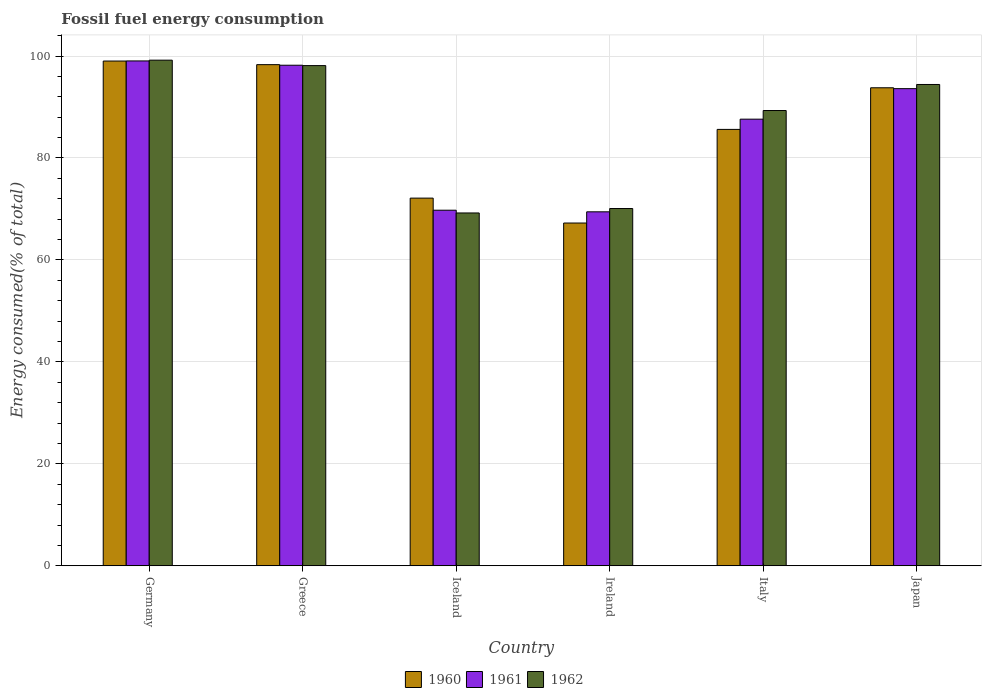How many different coloured bars are there?
Provide a succinct answer. 3. How many bars are there on the 1st tick from the left?
Your answer should be compact. 3. What is the percentage of energy consumed in 1960 in Ireland?
Offer a very short reply. 67.24. Across all countries, what is the maximum percentage of energy consumed in 1960?
Keep it short and to the point. 99.02. Across all countries, what is the minimum percentage of energy consumed in 1961?
Offer a very short reply. 69.44. In which country was the percentage of energy consumed in 1960 maximum?
Your answer should be very brief. Germany. In which country was the percentage of energy consumed in 1961 minimum?
Your response must be concise. Ireland. What is the total percentage of energy consumed in 1960 in the graph?
Give a very brief answer. 516.09. What is the difference between the percentage of energy consumed in 1960 in Iceland and that in Ireland?
Offer a terse response. 4.89. What is the difference between the percentage of energy consumed in 1961 in Greece and the percentage of energy consumed in 1960 in Italy?
Your answer should be compact. 12.59. What is the average percentage of energy consumed in 1961 per country?
Provide a short and direct response. 86.28. What is the difference between the percentage of energy consumed of/in 1961 and percentage of energy consumed of/in 1962 in Iceland?
Provide a short and direct response. 0.54. In how many countries, is the percentage of energy consumed in 1960 greater than 72 %?
Your answer should be very brief. 5. What is the ratio of the percentage of energy consumed in 1961 in Germany to that in Iceland?
Provide a short and direct response. 1.42. What is the difference between the highest and the second highest percentage of energy consumed in 1962?
Ensure brevity in your answer.  -1.07. What is the difference between the highest and the lowest percentage of energy consumed in 1961?
Your answer should be compact. 29.6. In how many countries, is the percentage of energy consumed in 1962 greater than the average percentage of energy consumed in 1962 taken over all countries?
Keep it short and to the point. 4. How many bars are there?
Offer a very short reply. 18. How many countries are there in the graph?
Give a very brief answer. 6. Does the graph contain any zero values?
Your answer should be compact. No. Does the graph contain grids?
Provide a succinct answer. Yes. Where does the legend appear in the graph?
Your response must be concise. Bottom center. What is the title of the graph?
Your answer should be compact. Fossil fuel energy consumption. What is the label or title of the Y-axis?
Make the answer very short. Energy consumed(% of total). What is the Energy consumed(% of total) of 1960 in Germany?
Give a very brief answer. 99.02. What is the Energy consumed(% of total) of 1961 in Germany?
Offer a terse response. 99.04. What is the Energy consumed(% of total) in 1962 in Germany?
Keep it short and to the point. 99.19. What is the Energy consumed(% of total) of 1960 in Greece?
Make the answer very short. 98.31. What is the Energy consumed(% of total) in 1961 in Greece?
Your answer should be very brief. 98.2. What is the Energy consumed(% of total) in 1962 in Greece?
Make the answer very short. 98.12. What is the Energy consumed(% of total) in 1960 in Iceland?
Offer a terse response. 72.13. What is the Energy consumed(% of total) of 1961 in Iceland?
Provide a succinct answer. 69.76. What is the Energy consumed(% of total) of 1962 in Iceland?
Provide a succinct answer. 69.22. What is the Energy consumed(% of total) in 1960 in Ireland?
Your answer should be compact. 67.24. What is the Energy consumed(% of total) in 1961 in Ireland?
Offer a terse response. 69.44. What is the Energy consumed(% of total) in 1962 in Ireland?
Ensure brevity in your answer.  70.09. What is the Energy consumed(% of total) of 1960 in Italy?
Give a very brief answer. 85.61. What is the Energy consumed(% of total) in 1961 in Italy?
Your answer should be compact. 87.62. What is the Energy consumed(% of total) in 1962 in Italy?
Your answer should be compact. 89.31. What is the Energy consumed(% of total) of 1960 in Japan?
Make the answer very short. 93.78. What is the Energy consumed(% of total) of 1961 in Japan?
Your answer should be compact. 93.6. What is the Energy consumed(% of total) of 1962 in Japan?
Your answer should be very brief. 94.42. Across all countries, what is the maximum Energy consumed(% of total) of 1960?
Give a very brief answer. 99.02. Across all countries, what is the maximum Energy consumed(% of total) in 1961?
Your answer should be very brief. 99.04. Across all countries, what is the maximum Energy consumed(% of total) in 1962?
Keep it short and to the point. 99.19. Across all countries, what is the minimum Energy consumed(% of total) of 1960?
Provide a short and direct response. 67.24. Across all countries, what is the minimum Energy consumed(% of total) of 1961?
Your answer should be compact. 69.44. Across all countries, what is the minimum Energy consumed(% of total) of 1962?
Your answer should be very brief. 69.22. What is the total Energy consumed(% of total) in 1960 in the graph?
Provide a short and direct response. 516.09. What is the total Energy consumed(% of total) in 1961 in the graph?
Provide a succinct answer. 517.66. What is the total Energy consumed(% of total) of 1962 in the graph?
Your answer should be very brief. 520.35. What is the difference between the Energy consumed(% of total) of 1960 in Germany and that in Greece?
Keep it short and to the point. 0.71. What is the difference between the Energy consumed(% of total) of 1961 in Germany and that in Greece?
Your response must be concise. 0.84. What is the difference between the Energy consumed(% of total) in 1962 in Germany and that in Greece?
Provide a succinct answer. 1.07. What is the difference between the Energy consumed(% of total) in 1960 in Germany and that in Iceland?
Ensure brevity in your answer.  26.89. What is the difference between the Energy consumed(% of total) of 1961 in Germany and that in Iceland?
Keep it short and to the point. 29.28. What is the difference between the Energy consumed(% of total) of 1962 in Germany and that in Iceland?
Your response must be concise. 29.98. What is the difference between the Energy consumed(% of total) in 1960 in Germany and that in Ireland?
Keep it short and to the point. 31.78. What is the difference between the Energy consumed(% of total) of 1961 in Germany and that in Ireland?
Give a very brief answer. 29.6. What is the difference between the Energy consumed(% of total) of 1962 in Germany and that in Ireland?
Provide a short and direct response. 29.11. What is the difference between the Energy consumed(% of total) in 1960 in Germany and that in Italy?
Offer a terse response. 13.41. What is the difference between the Energy consumed(% of total) in 1961 in Germany and that in Italy?
Provide a succinct answer. 11.42. What is the difference between the Energy consumed(% of total) in 1962 in Germany and that in Italy?
Keep it short and to the point. 9.88. What is the difference between the Energy consumed(% of total) in 1960 in Germany and that in Japan?
Your answer should be compact. 5.24. What is the difference between the Energy consumed(% of total) in 1961 in Germany and that in Japan?
Keep it short and to the point. 5.44. What is the difference between the Energy consumed(% of total) in 1962 in Germany and that in Japan?
Keep it short and to the point. 4.77. What is the difference between the Energy consumed(% of total) of 1960 in Greece and that in Iceland?
Offer a very short reply. 26.18. What is the difference between the Energy consumed(% of total) of 1961 in Greece and that in Iceland?
Your answer should be compact. 28.44. What is the difference between the Energy consumed(% of total) in 1962 in Greece and that in Iceland?
Provide a succinct answer. 28.91. What is the difference between the Energy consumed(% of total) of 1960 in Greece and that in Ireland?
Your answer should be very brief. 31.07. What is the difference between the Energy consumed(% of total) of 1961 in Greece and that in Ireland?
Offer a terse response. 28.76. What is the difference between the Energy consumed(% of total) in 1962 in Greece and that in Ireland?
Your answer should be compact. 28.04. What is the difference between the Energy consumed(% of total) of 1960 in Greece and that in Italy?
Your answer should be very brief. 12.7. What is the difference between the Energy consumed(% of total) in 1961 in Greece and that in Italy?
Keep it short and to the point. 10.58. What is the difference between the Energy consumed(% of total) of 1962 in Greece and that in Italy?
Your response must be concise. 8.81. What is the difference between the Energy consumed(% of total) in 1960 in Greece and that in Japan?
Provide a succinct answer. 4.53. What is the difference between the Energy consumed(% of total) of 1961 in Greece and that in Japan?
Offer a terse response. 4.6. What is the difference between the Energy consumed(% of total) in 1962 in Greece and that in Japan?
Provide a succinct answer. 3.7. What is the difference between the Energy consumed(% of total) of 1960 in Iceland and that in Ireland?
Offer a terse response. 4.89. What is the difference between the Energy consumed(% of total) of 1961 in Iceland and that in Ireland?
Offer a terse response. 0.32. What is the difference between the Energy consumed(% of total) of 1962 in Iceland and that in Ireland?
Ensure brevity in your answer.  -0.87. What is the difference between the Energy consumed(% of total) of 1960 in Iceland and that in Italy?
Provide a succinct answer. -13.48. What is the difference between the Energy consumed(% of total) of 1961 in Iceland and that in Italy?
Offer a very short reply. -17.86. What is the difference between the Energy consumed(% of total) of 1962 in Iceland and that in Italy?
Your response must be concise. -20.09. What is the difference between the Energy consumed(% of total) in 1960 in Iceland and that in Japan?
Your response must be concise. -21.65. What is the difference between the Energy consumed(% of total) of 1961 in Iceland and that in Japan?
Your answer should be compact. -23.85. What is the difference between the Energy consumed(% of total) of 1962 in Iceland and that in Japan?
Your response must be concise. -25.2. What is the difference between the Energy consumed(% of total) in 1960 in Ireland and that in Italy?
Your response must be concise. -18.37. What is the difference between the Energy consumed(% of total) in 1961 in Ireland and that in Italy?
Keep it short and to the point. -18.18. What is the difference between the Energy consumed(% of total) of 1962 in Ireland and that in Italy?
Keep it short and to the point. -19.23. What is the difference between the Energy consumed(% of total) in 1960 in Ireland and that in Japan?
Give a very brief answer. -26.53. What is the difference between the Energy consumed(% of total) of 1961 in Ireland and that in Japan?
Keep it short and to the point. -24.16. What is the difference between the Energy consumed(% of total) in 1962 in Ireland and that in Japan?
Your answer should be very brief. -24.34. What is the difference between the Energy consumed(% of total) of 1960 in Italy and that in Japan?
Provide a short and direct response. -8.17. What is the difference between the Energy consumed(% of total) in 1961 in Italy and that in Japan?
Offer a very short reply. -5.99. What is the difference between the Energy consumed(% of total) in 1962 in Italy and that in Japan?
Keep it short and to the point. -5.11. What is the difference between the Energy consumed(% of total) of 1960 in Germany and the Energy consumed(% of total) of 1961 in Greece?
Your answer should be compact. 0.82. What is the difference between the Energy consumed(% of total) in 1960 in Germany and the Energy consumed(% of total) in 1962 in Greece?
Provide a short and direct response. 0.9. What is the difference between the Energy consumed(% of total) in 1961 in Germany and the Energy consumed(% of total) in 1962 in Greece?
Your answer should be very brief. 0.92. What is the difference between the Energy consumed(% of total) of 1960 in Germany and the Energy consumed(% of total) of 1961 in Iceland?
Offer a very short reply. 29.26. What is the difference between the Energy consumed(% of total) of 1960 in Germany and the Energy consumed(% of total) of 1962 in Iceland?
Keep it short and to the point. 29.8. What is the difference between the Energy consumed(% of total) of 1961 in Germany and the Energy consumed(% of total) of 1962 in Iceland?
Ensure brevity in your answer.  29.82. What is the difference between the Energy consumed(% of total) of 1960 in Germany and the Energy consumed(% of total) of 1961 in Ireland?
Offer a very short reply. 29.58. What is the difference between the Energy consumed(% of total) of 1960 in Germany and the Energy consumed(% of total) of 1962 in Ireland?
Provide a short and direct response. 28.93. What is the difference between the Energy consumed(% of total) in 1961 in Germany and the Energy consumed(% of total) in 1962 in Ireland?
Provide a short and direct response. 28.96. What is the difference between the Energy consumed(% of total) of 1960 in Germany and the Energy consumed(% of total) of 1961 in Italy?
Your answer should be compact. 11.4. What is the difference between the Energy consumed(% of total) in 1960 in Germany and the Energy consumed(% of total) in 1962 in Italy?
Keep it short and to the point. 9.71. What is the difference between the Energy consumed(% of total) of 1961 in Germany and the Energy consumed(% of total) of 1962 in Italy?
Ensure brevity in your answer.  9.73. What is the difference between the Energy consumed(% of total) in 1960 in Germany and the Energy consumed(% of total) in 1961 in Japan?
Keep it short and to the point. 5.42. What is the difference between the Energy consumed(% of total) in 1960 in Germany and the Energy consumed(% of total) in 1962 in Japan?
Ensure brevity in your answer.  4.6. What is the difference between the Energy consumed(% of total) of 1961 in Germany and the Energy consumed(% of total) of 1962 in Japan?
Your answer should be very brief. 4.62. What is the difference between the Energy consumed(% of total) in 1960 in Greece and the Energy consumed(% of total) in 1961 in Iceland?
Keep it short and to the point. 28.55. What is the difference between the Energy consumed(% of total) of 1960 in Greece and the Energy consumed(% of total) of 1962 in Iceland?
Offer a very short reply. 29.09. What is the difference between the Energy consumed(% of total) of 1961 in Greece and the Energy consumed(% of total) of 1962 in Iceland?
Provide a succinct answer. 28.98. What is the difference between the Energy consumed(% of total) of 1960 in Greece and the Energy consumed(% of total) of 1961 in Ireland?
Your answer should be compact. 28.87. What is the difference between the Energy consumed(% of total) of 1960 in Greece and the Energy consumed(% of total) of 1962 in Ireland?
Your answer should be compact. 28.23. What is the difference between the Energy consumed(% of total) of 1961 in Greece and the Energy consumed(% of total) of 1962 in Ireland?
Provide a short and direct response. 28.11. What is the difference between the Energy consumed(% of total) of 1960 in Greece and the Energy consumed(% of total) of 1961 in Italy?
Your response must be concise. 10.69. What is the difference between the Energy consumed(% of total) in 1960 in Greece and the Energy consumed(% of total) in 1962 in Italy?
Keep it short and to the point. 9. What is the difference between the Energy consumed(% of total) in 1961 in Greece and the Energy consumed(% of total) in 1962 in Italy?
Your answer should be compact. 8.89. What is the difference between the Energy consumed(% of total) in 1960 in Greece and the Energy consumed(% of total) in 1961 in Japan?
Ensure brevity in your answer.  4.71. What is the difference between the Energy consumed(% of total) of 1960 in Greece and the Energy consumed(% of total) of 1962 in Japan?
Your answer should be compact. 3.89. What is the difference between the Energy consumed(% of total) in 1961 in Greece and the Energy consumed(% of total) in 1962 in Japan?
Your response must be concise. 3.78. What is the difference between the Energy consumed(% of total) in 1960 in Iceland and the Energy consumed(% of total) in 1961 in Ireland?
Keep it short and to the point. 2.69. What is the difference between the Energy consumed(% of total) of 1960 in Iceland and the Energy consumed(% of total) of 1962 in Ireland?
Your response must be concise. 2.04. What is the difference between the Energy consumed(% of total) of 1961 in Iceland and the Energy consumed(% of total) of 1962 in Ireland?
Make the answer very short. -0.33. What is the difference between the Energy consumed(% of total) of 1960 in Iceland and the Energy consumed(% of total) of 1961 in Italy?
Make the answer very short. -15.49. What is the difference between the Energy consumed(% of total) of 1960 in Iceland and the Energy consumed(% of total) of 1962 in Italy?
Provide a succinct answer. -17.18. What is the difference between the Energy consumed(% of total) of 1961 in Iceland and the Energy consumed(% of total) of 1962 in Italy?
Your answer should be very brief. -19.55. What is the difference between the Energy consumed(% of total) in 1960 in Iceland and the Energy consumed(% of total) in 1961 in Japan?
Your answer should be very brief. -21.48. What is the difference between the Energy consumed(% of total) of 1960 in Iceland and the Energy consumed(% of total) of 1962 in Japan?
Offer a terse response. -22.29. What is the difference between the Energy consumed(% of total) of 1961 in Iceland and the Energy consumed(% of total) of 1962 in Japan?
Offer a very short reply. -24.66. What is the difference between the Energy consumed(% of total) in 1960 in Ireland and the Energy consumed(% of total) in 1961 in Italy?
Give a very brief answer. -20.38. What is the difference between the Energy consumed(% of total) of 1960 in Ireland and the Energy consumed(% of total) of 1962 in Italy?
Your response must be concise. -22.07. What is the difference between the Energy consumed(% of total) in 1961 in Ireland and the Energy consumed(% of total) in 1962 in Italy?
Your answer should be very brief. -19.87. What is the difference between the Energy consumed(% of total) in 1960 in Ireland and the Energy consumed(% of total) in 1961 in Japan?
Make the answer very short. -26.36. What is the difference between the Energy consumed(% of total) in 1960 in Ireland and the Energy consumed(% of total) in 1962 in Japan?
Make the answer very short. -27.18. What is the difference between the Energy consumed(% of total) of 1961 in Ireland and the Energy consumed(% of total) of 1962 in Japan?
Your answer should be compact. -24.98. What is the difference between the Energy consumed(% of total) in 1960 in Italy and the Energy consumed(% of total) in 1961 in Japan?
Provide a succinct answer. -7.99. What is the difference between the Energy consumed(% of total) of 1960 in Italy and the Energy consumed(% of total) of 1962 in Japan?
Your answer should be very brief. -8.81. What is the difference between the Energy consumed(% of total) of 1961 in Italy and the Energy consumed(% of total) of 1962 in Japan?
Keep it short and to the point. -6.8. What is the average Energy consumed(% of total) of 1960 per country?
Your answer should be very brief. 86.01. What is the average Energy consumed(% of total) in 1961 per country?
Offer a very short reply. 86.28. What is the average Energy consumed(% of total) of 1962 per country?
Provide a succinct answer. 86.73. What is the difference between the Energy consumed(% of total) in 1960 and Energy consumed(% of total) in 1961 in Germany?
Your response must be concise. -0.02. What is the difference between the Energy consumed(% of total) of 1960 and Energy consumed(% of total) of 1962 in Germany?
Keep it short and to the point. -0.17. What is the difference between the Energy consumed(% of total) of 1961 and Energy consumed(% of total) of 1962 in Germany?
Provide a succinct answer. -0.15. What is the difference between the Energy consumed(% of total) of 1960 and Energy consumed(% of total) of 1961 in Greece?
Provide a succinct answer. 0.11. What is the difference between the Energy consumed(% of total) in 1960 and Energy consumed(% of total) in 1962 in Greece?
Provide a short and direct response. 0.19. What is the difference between the Energy consumed(% of total) in 1961 and Energy consumed(% of total) in 1962 in Greece?
Your answer should be very brief. 0.07. What is the difference between the Energy consumed(% of total) in 1960 and Energy consumed(% of total) in 1961 in Iceland?
Your response must be concise. 2.37. What is the difference between the Energy consumed(% of total) in 1960 and Energy consumed(% of total) in 1962 in Iceland?
Your response must be concise. 2.91. What is the difference between the Energy consumed(% of total) of 1961 and Energy consumed(% of total) of 1962 in Iceland?
Offer a terse response. 0.54. What is the difference between the Energy consumed(% of total) of 1960 and Energy consumed(% of total) of 1961 in Ireland?
Your response must be concise. -2.2. What is the difference between the Energy consumed(% of total) of 1960 and Energy consumed(% of total) of 1962 in Ireland?
Offer a terse response. -2.84. What is the difference between the Energy consumed(% of total) in 1961 and Energy consumed(% of total) in 1962 in Ireland?
Your answer should be very brief. -0.65. What is the difference between the Energy consumed(% of total) of 1960 and Energy consumed(% of total) of 1961 in Italy?
Your answer should be compact. -2.01. What is the difference between the Energy consumed(% of total) of 1960 and Energy consumed(% of total) of 1962 in Italy?
Provide a short and direct response. -3.7. What is the difference between the Energy consumed(% of total) of 1961 and Energy consumed(% of total) of 1962 in Italy?
Keep it short and to the point. -1.69. What is the difference between the Energy consumed(% of total) in 1960 and Energy consumed(% of total) in 1961 in Japan?
Keep it short and to the point. 0.17. What is the difference between the Energy consumed(% of total) of 1960 and Energy consumed(% of total) of 1962 in Japan?
Ensure brevity in your answer.  -0.64. What is the difference between the Energy consumed(% of total) in 1961 and Energy consumed(% of total) in 1962 in Japan?
Your answer should be very brief. -0.82. What is the ratio of the Energy consumed(% of total) of 1960 in Germany to that in Greece?
Keep it short and to the point. 1.01. What is the ratio of the Energy consumed(% of total) of 1961 in Germany to that in Greece?
Offer a very short reply. 1.01. What is the ratio of the Energy consumed(% of total) in 1962 in Germany to that in Greece?
Your response must be concise. 1.01. What is the ratio of the Energy consumed(% of total) in 1960 in Germany to that in Iceland?
Provide a short and direct response. 1.37. What is the ratio of the Energy consumed(% of total) in 1961 in Germany to that in Iceland?
Your response must be concise. 1.42. What is the ratio of the Energy consumed(% of total) in 1962 in Germany to that in Iceland?
Keep it short and to the point. 1.43. What is the ratio of the Energy consumed(% of total) of 1960 in Germany to that in Ireland?
Provide a succinct answer. 1.47. What is the ratio of the Energy consumed(% of total) of 1961 in Germany to that in Ireland?
Provide a short and direct response. 1.43. What is the ratio of the Energy consumed(% of total) of 1962 in Germany to that in Ireland?
Provide a short and direct response. 1.42. What is the ratio of the Energy consumed(% of total) in 1960 in Germany to that in Italy?
Your answer should be very brief. 1.16. What is the ratio of the Energy consumed(% of total) of 1961 in Germany to that in Italy?
Offer a terse response. 1.13. What is the ratio of the Energy consumed(% of total) of 1962 in Germany to that in Italy?
Ensure brevity in your answer.  1.11. What is the ratio of the Energy consumed(% of total) in 1960 in Germany to that in Japan?
Offer a very short reply. 1.06. What is the ratio of the Energy consumed(% of total) of 1961 in Germany to that in Japan?
Your response must be concise. 1.06. What is the ratio of the Energy consumed(% of total) of 1962 in Germany to that in Japan?
Make the answer very short. 1.05. What is the ratio of the Energy consumed(% of total) in 1960 in Greece to that in Iceland?
Ensure brevity in your answer.  1.36. What is the ratio of the Energy consumed(% of total) of 1961 in Greece to that in Iceland?
Ensure brevity in your answer.  1.41. What is the ratio of the Energy consumed(% of total) of 1962 in Greece to that in Iceland?
Your answer should be compact. 1.42. What is the ratio of the Energy consumed(% of total) of 1960 in Greece to that in Ireland?
Your answer should be very brief. 1.46. What is the ratio of the Energy consumed(% of total) in 1961 in Greece to that in Ireland?
Your answer should be compact. 1.41. What is the ratio of the Energy consumed(% of total) of 1962 in Greece to that in Ireland?
Offer a very short reply. 1.4. What is the ratio of the Energy consumed(% of total) in 1960 in Greece to that in Italy?
Provide a short and direct response. 1.15. What is the ratio of the Energy consumed(% of total) of 1961 in Greece to that in Italy?
Offer a very short reply. 1.12. What is the ratio of the Energy consumed(% of total) of 1962 in Greece to that in Italy?
Your answer should be compact. 1.1. What is the ratio of the Energy consumed(% of total) of 1960 in Greece to that in Japan?
Your answer should be compact. 1.05. What is the ratio of the Energy consumed(% of total) in 1961 in Greece to that in Japan?
Give a very brief answer. 1.05. What is the ratio of the Energy consumed(% of total) of 1962 in Greece to that in Japan?
Give a very brief answer. 1.04. What is the ratio of the Energy consumed(% of total) of 1960 in Iceland to that in Ireland?
Make the answer very short. 1.07. What is the ratio of the Energy consumed(% of total) of 1961 in Iceland to that in Ireland?
Offer a very short reply. 1. What is the ratio of the Energy consumed(% of total) in 1962 in Iceland to that in Ireland?
Make the answer very short. 0.99. What is the ratio of the Energy consumed(% of total) of 1960 in Iceland to that in Italy?
Provide a short and direct response. 0.84. What is the ratio of the Energy consumed(% of total) in 1961 in Iceland to that in Italy?
Give a very brief answer. 0.8. What is the ratio of the Energy consumed(% of total) of 1962 in Iceland to that in Italy?
Your answer should be very brief. 0.78. What is the ratio of the Energy consumed(% of total) in 1960 in Iceland to that in Japan?
Your response must be concise. 0.77. What is the ratio of the Energy consumed(% of total) in 1961 in Iceland to that in Japan?
Your answer should be very brief. 0.75. What is the ratio of the Energy consumed(% of total) of 1962 in Iceland to that in Japan?
Your answer should be very brief. 0.73. What is the ratio of the Energy consumed(% of total) of 1960 in Ireland to that in Italy?
Offer a very short reply. 0.79. What is the ratio of the Energy consumed(% of total) in 1961 in Ireland to that in Italy?
Provide a succinct answer. 0.79. What is the ratio of the Energy consumed(% of total) of 1962 in Ireland to that in Italy?
Ensure brevity in your answer.  0.78. What is the ratio of the Energy consumed(% of total) in 1960 in Ireland to that in Japan?
Keep it short and to the point. 0.72. What is the ratio of the Energy consumed(% of total) in 1961 in Ireland to that in Japan?
Make the answer very short. 0.74. What is the ratio of the Energy consumed(% of total) of 1962 in Ireland to that in Japan?
Provide a succinct answer. 0.74. What is the ratio of the Energy consumed(% of total) of 1960 in Italy to that in Japan?
Provide a short and direct response. 0.91. What is the ratio of the Energy consumed(% of total) in 1961 in Italy to that in Japan?
Your answer should be compact. 0.94. What is the ratio of the Energy consumed(% of total) in 1962 in Italy to that in Japan?
Offer a very short reply. 0.95. What is the difference between the highest and the second highest Energy consumed(% of total) of 1960?
Make the answer very short. 0.71. What is the difference between the highest and the second highest Energy consumed(% of total) of 1961?
Offer a terse response. 0.84. What is the difference between the highest and the second highest Energy consumed(% of total) of 1962?
Make the answer very short. 1.07. What is the difference between the highest and the lowest Energy consumed(% of total) of 1960?
Provide a succinct answer. 31.78. What is the difference between the highest and the lowest Energy consumed(% of total) of 1961?
Your response must be concise. 29.6. What is the difference between the highest and the lowest Energy consumed(% of total) in 1962?
Give a very brief answer. 29.98. 